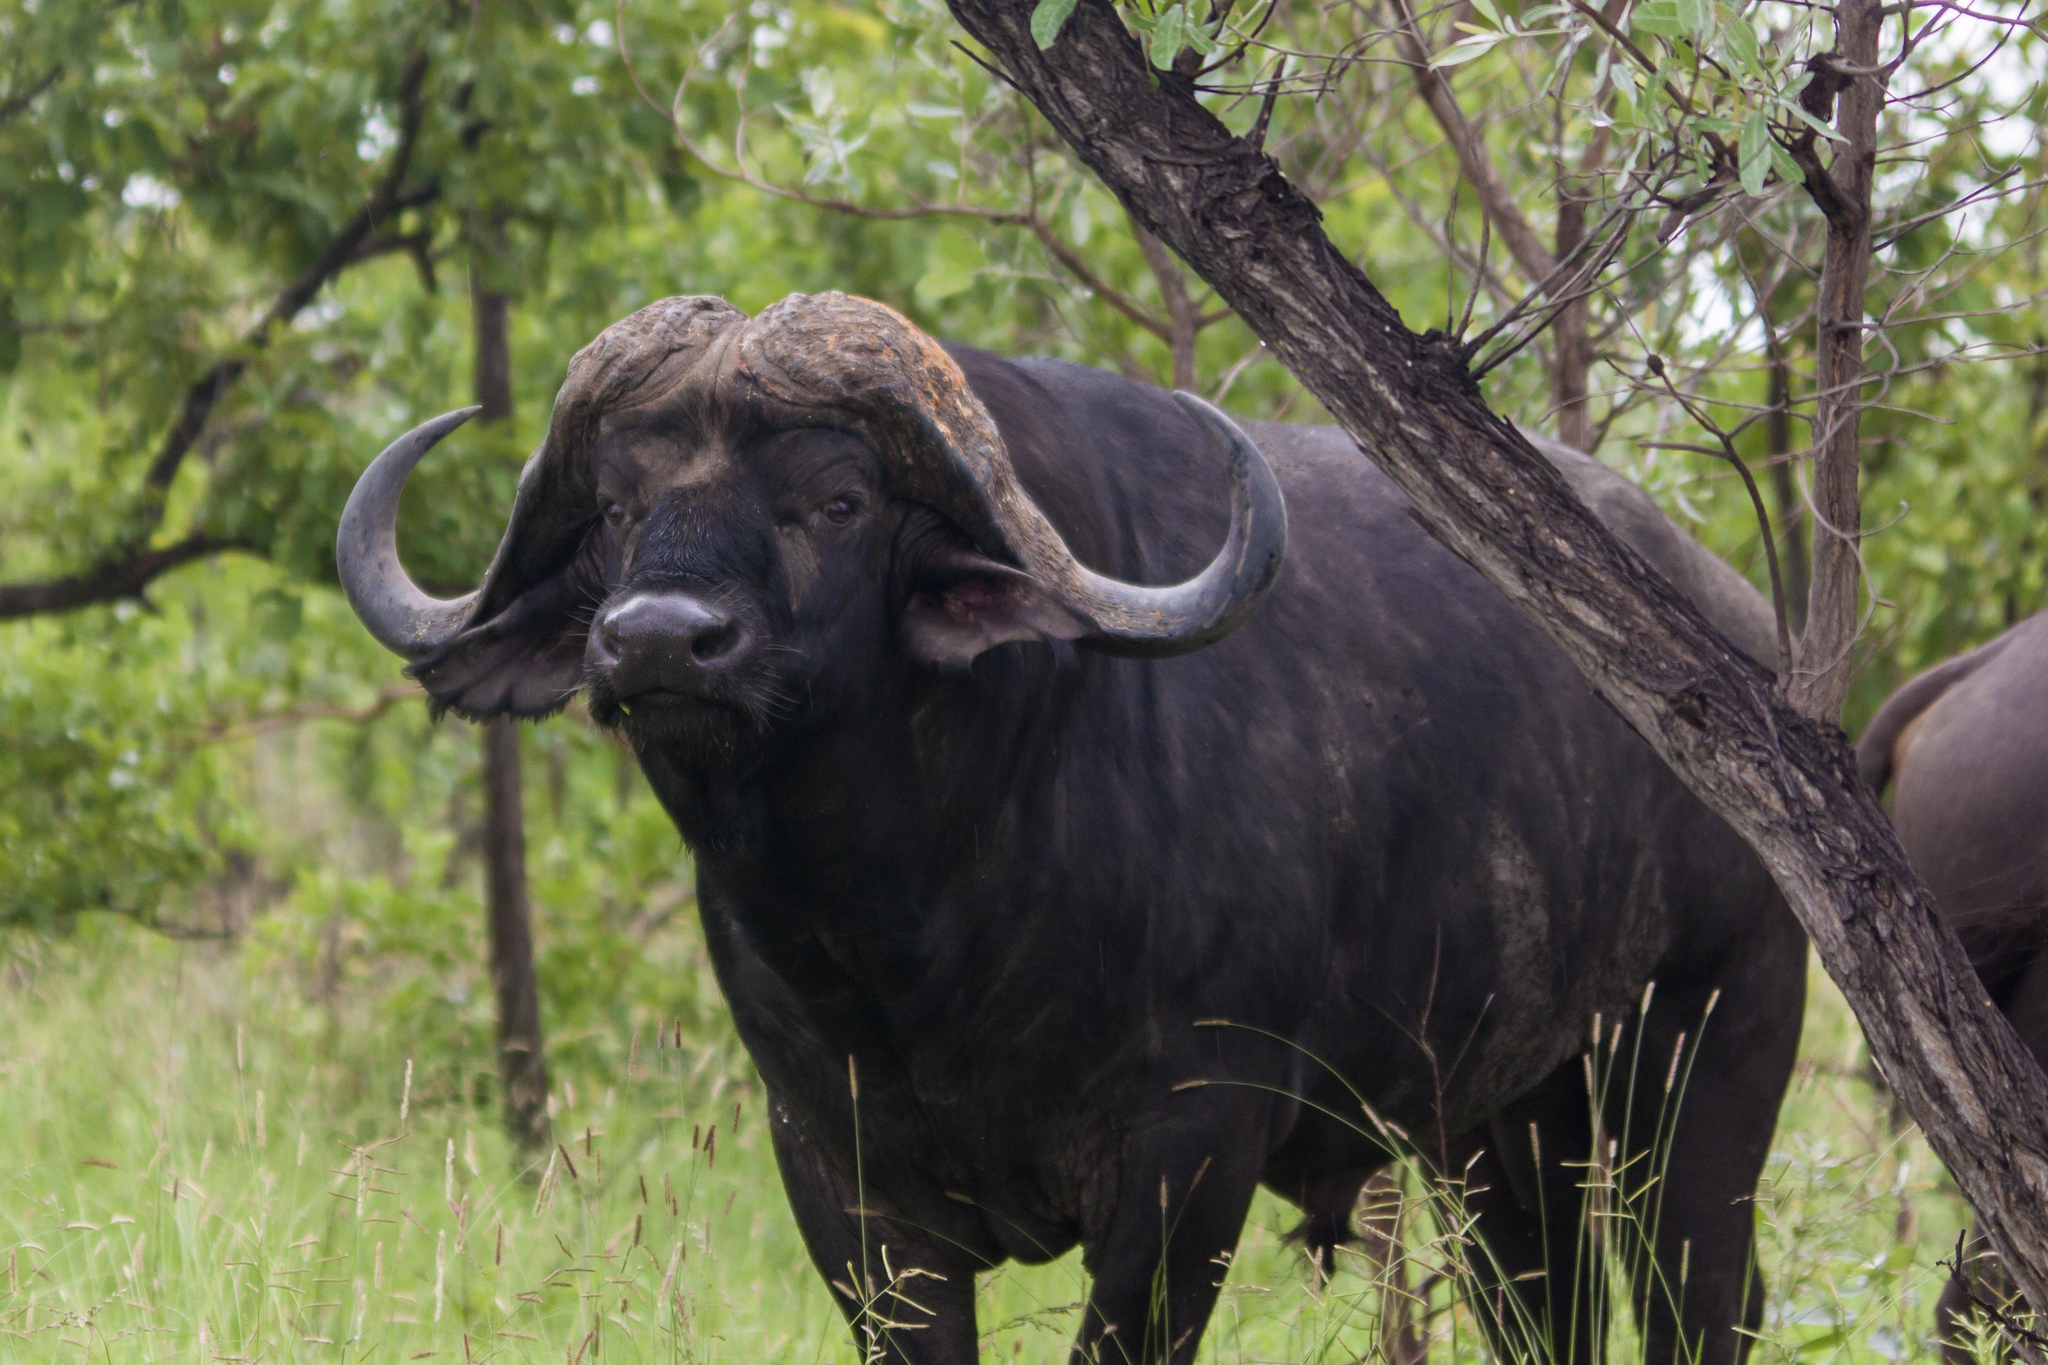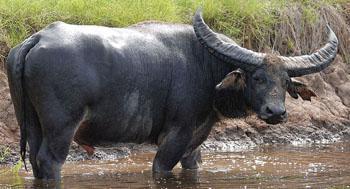The first image is the image on the left, the second image is the image on the right. Considering the images on both sides, is "One image shows at least four water buffalo." valid? Answer yes or no. No. The first image is the image on the left, the second image is the image on the right. Considering the images on both sides, is "There is more than one animal in the image on the right" valid? Answer yes or no. No. 